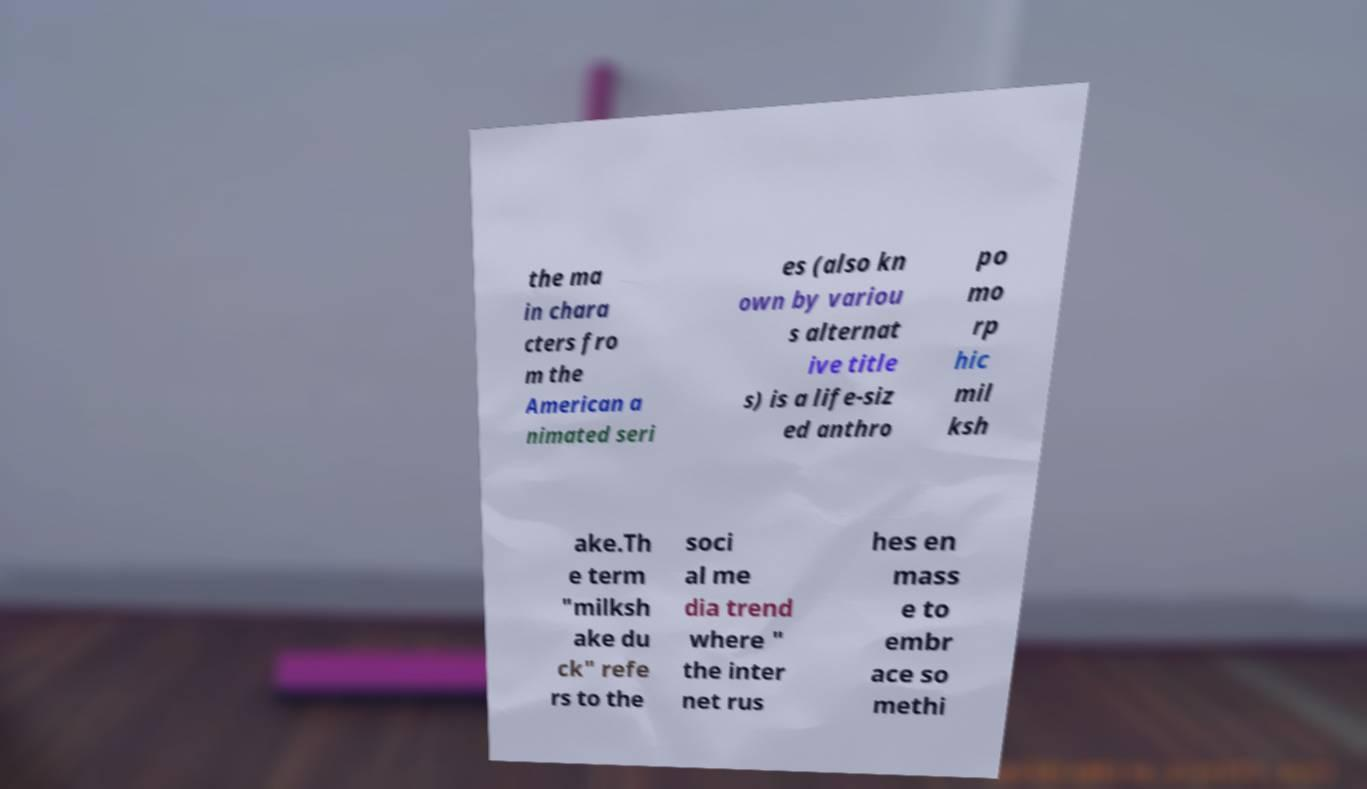Please identify and transcribe the text found in this image. the ma in chara cters fro m the American a nimated seri es (also kn own by variou s alternat ive title s) is a life-siz ed anthro po mo rp hic mil ksh ake.Th e term "milksh ake du ck" refe rs to the soci al me dia trend where " the inter net rus hes en mass e to embr ace so methi 